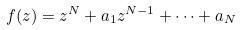Convert formula to latex. <formula><loc_0><loc_0><loc_500><loc_500>f ( z ) = z ^ { N } + a _ { 1 } z ^ { N - 1 } + \cdots + a _ { N }</formula> 